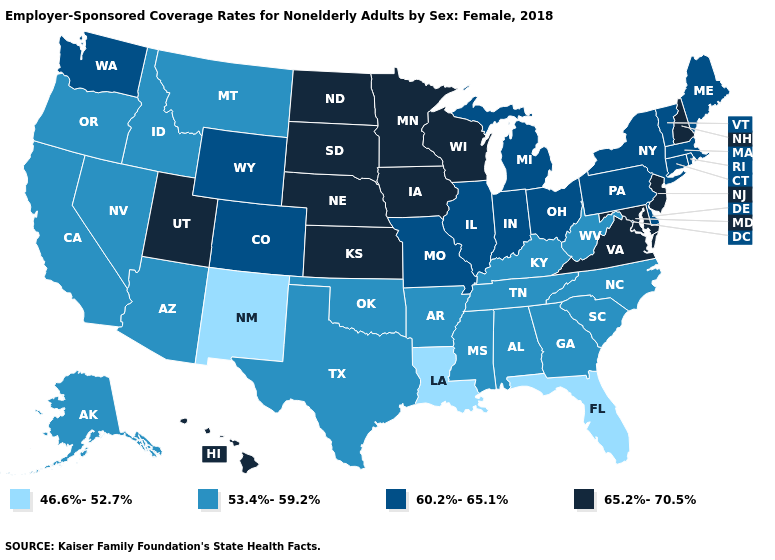Which states have the lowest value in the Northeast?
Write a very short answer. Connecticut, Maine, Massachusetts, New York, Pennsylvania, Rhode Island, Vermont. What is the value of Arizona?
Keep it brief. 53.4%-59.2%. Which states have the lowest value in the MidWest?
Concise answer only. Illinois, Indiana, Michigan, Missouri, Ohio. Name the states that have a value in the range 65.2%-70.5%?
Be succinct. Hawaii, Iowa, Kansas, Maryland, Minnesota, Nebraska, New Hampshire, New Jersey, North Dakota, South Dakota, Utah, Virginia, Wisconsin. What is the highest value in the USA?
Answer briefly. 65.2%-70.5%. What is the highest value in the South ?
Short answer required. 65.2%-70.5%. What is the value of Connecticut?
Keep it brief. 60.2%-65.1%. What is the lowest value in the USA?
Concise answer only. 46.6%-52.7%. What is the value of New York?
Keep it brief. 60.2%-65.1%. What is the highest value in the USA?
Write a very short answer. 65.2%-70.5%. What is the lowest value in states that border Missouri?
Keep it brief. 53.4%-59.2%. Is the legend a continuous bar?
Concise answer only. No. What is the lowest value in the South?
Concise answer only. 46.6%-52.7%. 